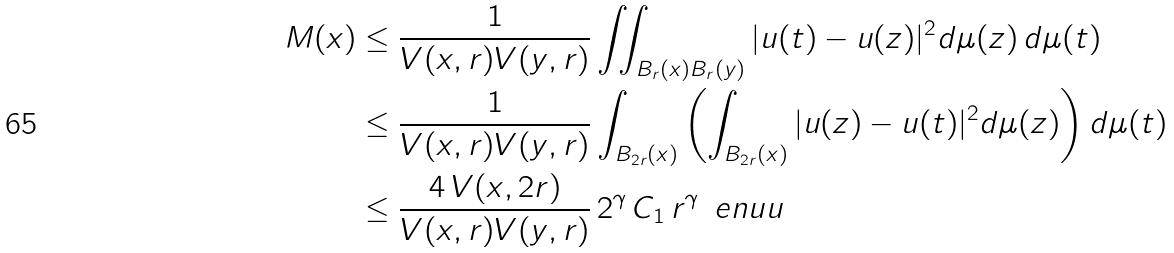<formula> <loc_0><loc_0><loc_500><loc_500>M ( x ) & \leq \frac { 1 } { V ( x , r ) V ( y , r ) } \iint _ { B _ { r } ( x ) B _ { r } ( y ) } | u ( t ) - u ( z ) | ^ { 2 } d \mu ( z ) \, d \mu ( t ) \\ & \leq \frac { 1 } { V ( x , r ) V ( y , r ) } \int _ { B _ { 2 r } ( x ) } \left ( \int _ { B _ { 2 r } ( x ) } | u ( z ) - u ( t ) | ^ { 2 } d \mu ( z ) \right ) d \mu ( t ) \\ & \leq \frac { 4 \, V ( x , 2 r ) } { V ( x , r ) V ( y , r ) } \, 2 ^ { \gamma } \, C _ { 1 } \, r ^ { \gamma } \, \ e n { u } { u } \,</formula> 